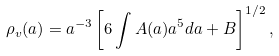Convert formula to latex. <formula><loc_0><loc_0><loc_500><loc_500>\rho _ { v } ( a ) = a ^ { - 3 } \left [ 6 \int A ( a ) a ^ { 5 } d a + B \right ] ^ { 1 / 2 } ,</formula> 